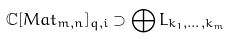<formula> <loc_0><loc_0><loc_500><loc_500>\mathbb { C } [ M a t _ { m , n } ] _ { q , i } \supset \bigoplus L _ { k _ { 1 } , \dots , k _ { m } }</formula> 